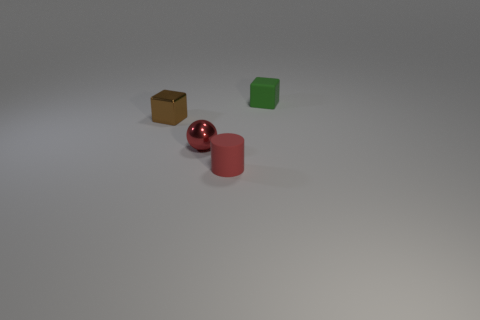Do the tiny green thing and the red rubber object have the same shape?
Provide a short and direct response. No. What number of other things are the same size as the red rubber object?
Provide a succinct answer. 3. Are there the same number of brown metal cubes that are on the right side of the tiny green rubber thing and large metallic things?
Make the answer very short. Yes. Does the matte object in front of the small red shiny sphere have the same color as the thing left of the red metallic sphere?
Provide a short and direct response. No. There is a object that is behind the red shiny sphere and to the right of the tiny metallic block; what is it made of?
Ensure brevity in your answer.  Rubber. What is the color of the small rubber block?
Your answer should be compact. Green. How many other objects are the same shape as the red metallic object?
Offer a very short reply. 0. Are there an equal number of green matte cubes to the right of the small green cube and tiny green cubes on the left side of the red metal object?
Your response must be concise. Yes. What is the material of the green block?
Keep it short and to the point. Rubber. What material is the tiny cube to the left of the tiny green thing?
Keep it short and to the point. Metal. 